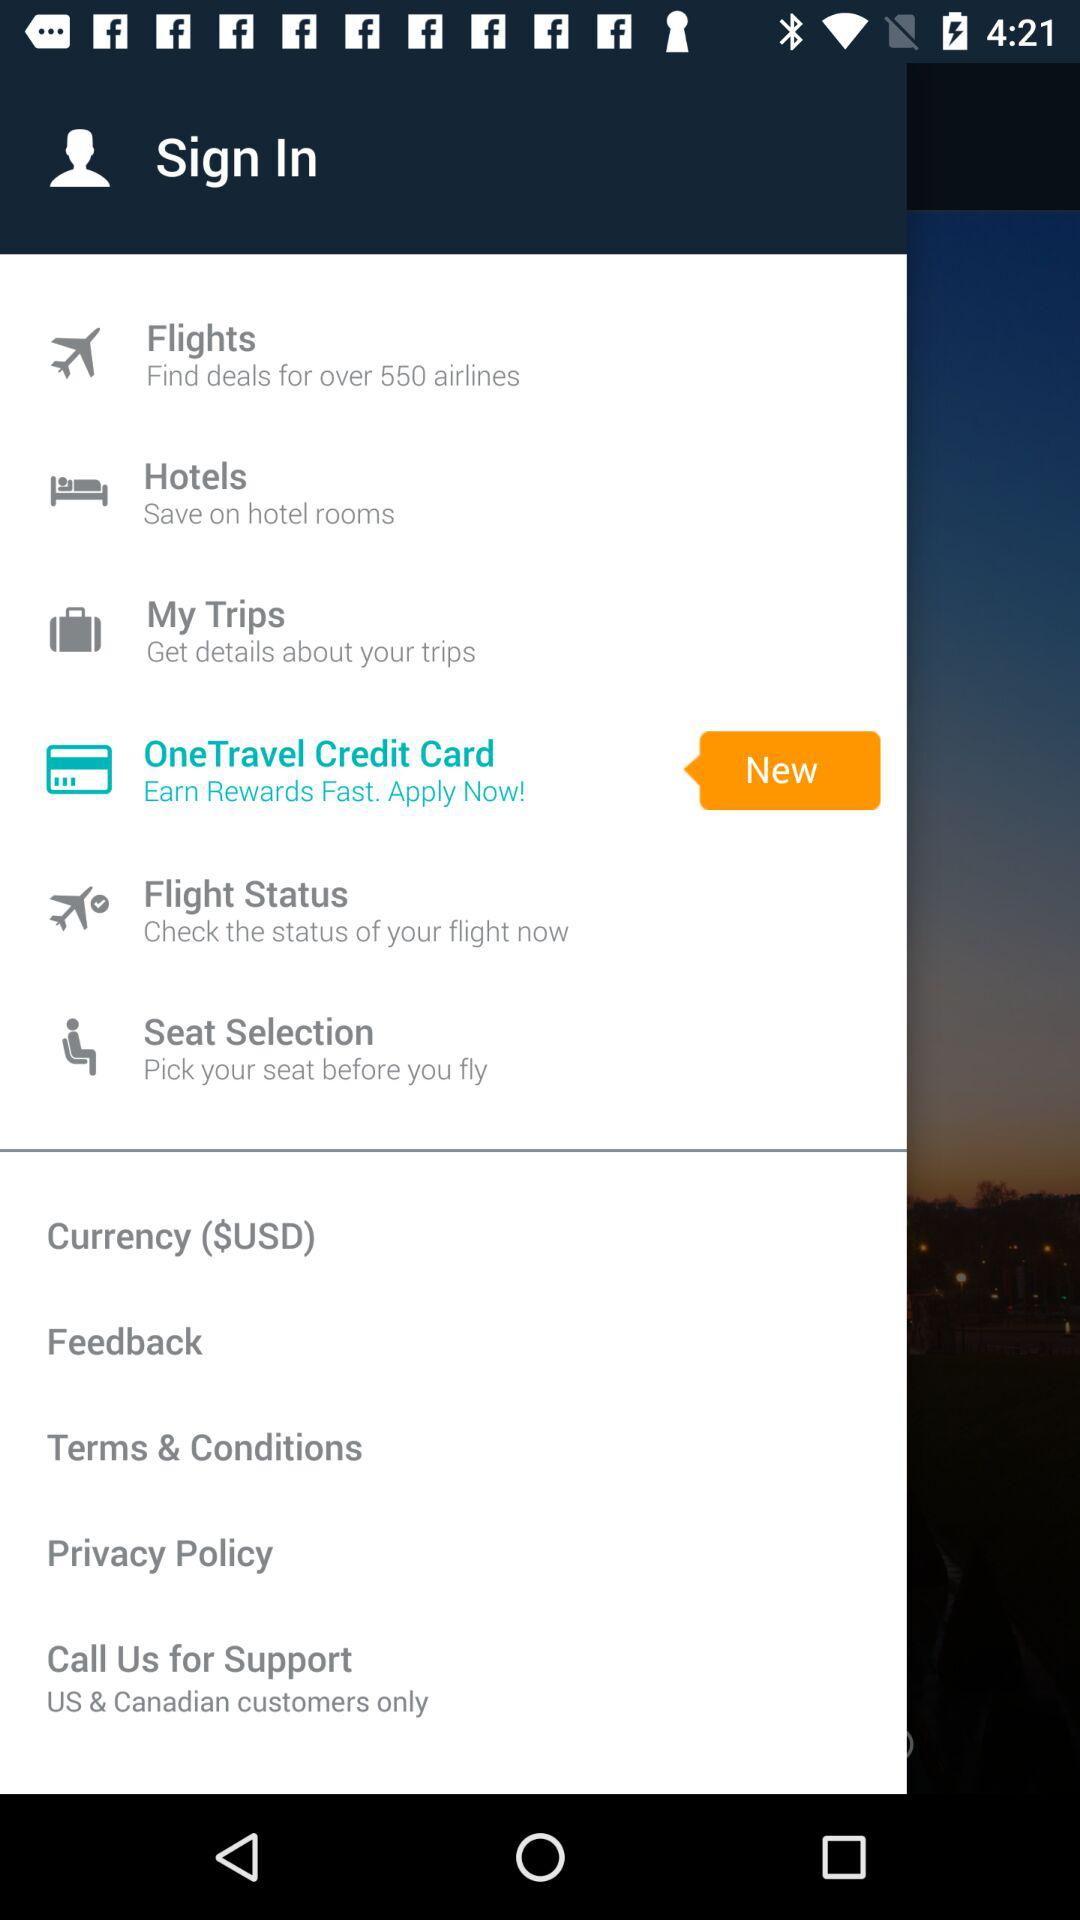Which option is selected? The selected option is "OneTravel Credit Card". 